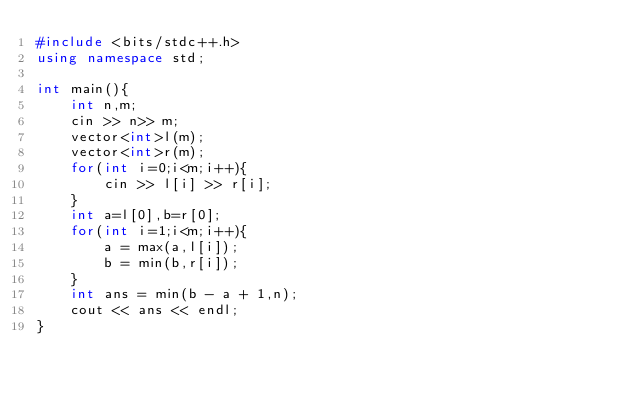<code> <loc_0><loc_0><loc_500><loc_500><_C++_>#include <bits/stdc++.h>
using namespace std;

int main(){
    int n,m;
    cin >> n>> m;
    vector<int>l(m);
    vector<int>r(m);
    for(int i=0;i<m;i++){
        cin >> l[i] >> r[i];
    }
    int a=l[0],b=r[0];
    for(int i=1;i<m;i++){
        a = max(a,l[i]);
        b = min(b,r[i]);
    }
    int ans = min(b - a + 1,n);
    cout << ans << endl;
}
</code> 